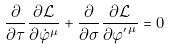<formula> <loc_0><loc_0><loc_500><loc_500>\frac { \partial } { \partial \tau } \frac { \partial { \mathcal { L } } } { \partial \dot { \varphi } ^ { \mu } } + \frac { \partial } { \partial \sigma } \frac { \partial { \mathcal { L } } } { \partial { \varphi ^ { ^ { \prime } } } ^ { \mu } } = 0</formula> 